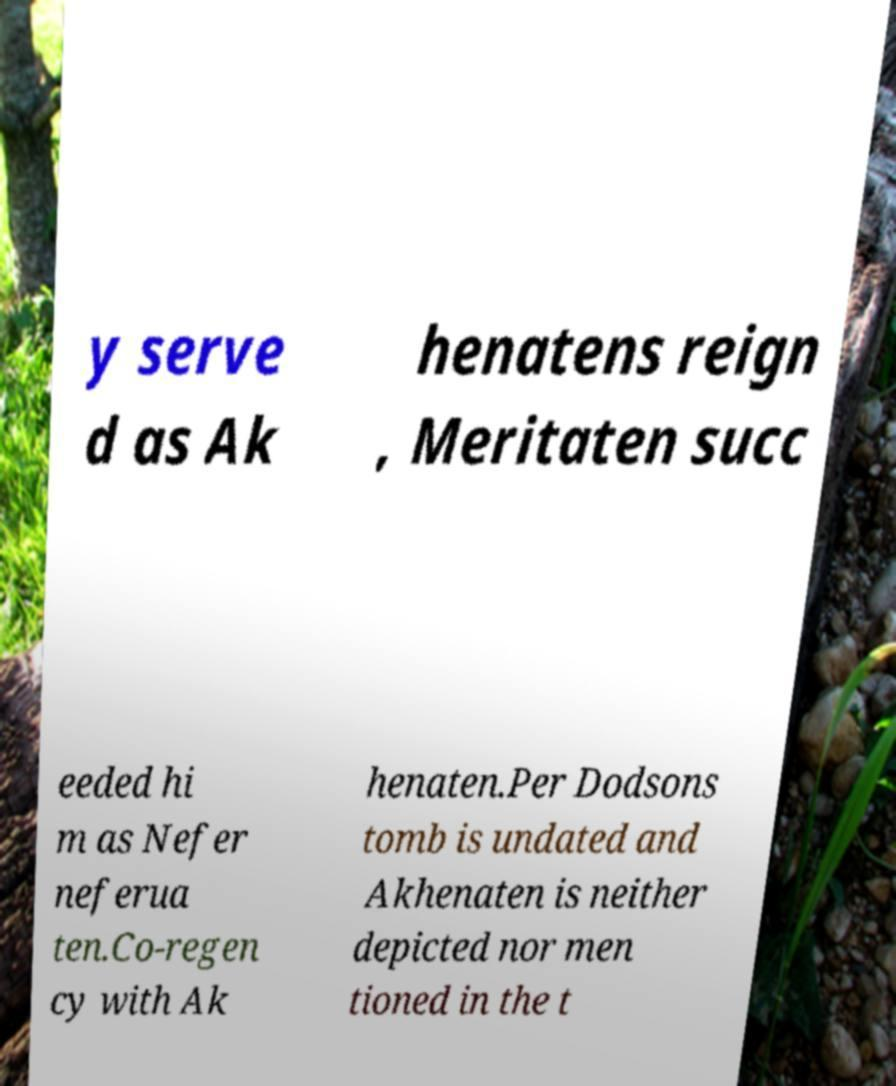Please read and relay the text visible in this image. What does it say? y serve d as Ak henatens reign , Meritaten succ eeded hi m as Nefer neferua ten.Co-regen cy with Ak henaten.Per Dodsons tomb is undated and Akhenaten is neither depicted nor men tioned in the t 